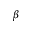<formula> <loc_0><loc_0><loc_500><loc_500>\beta</formula> 